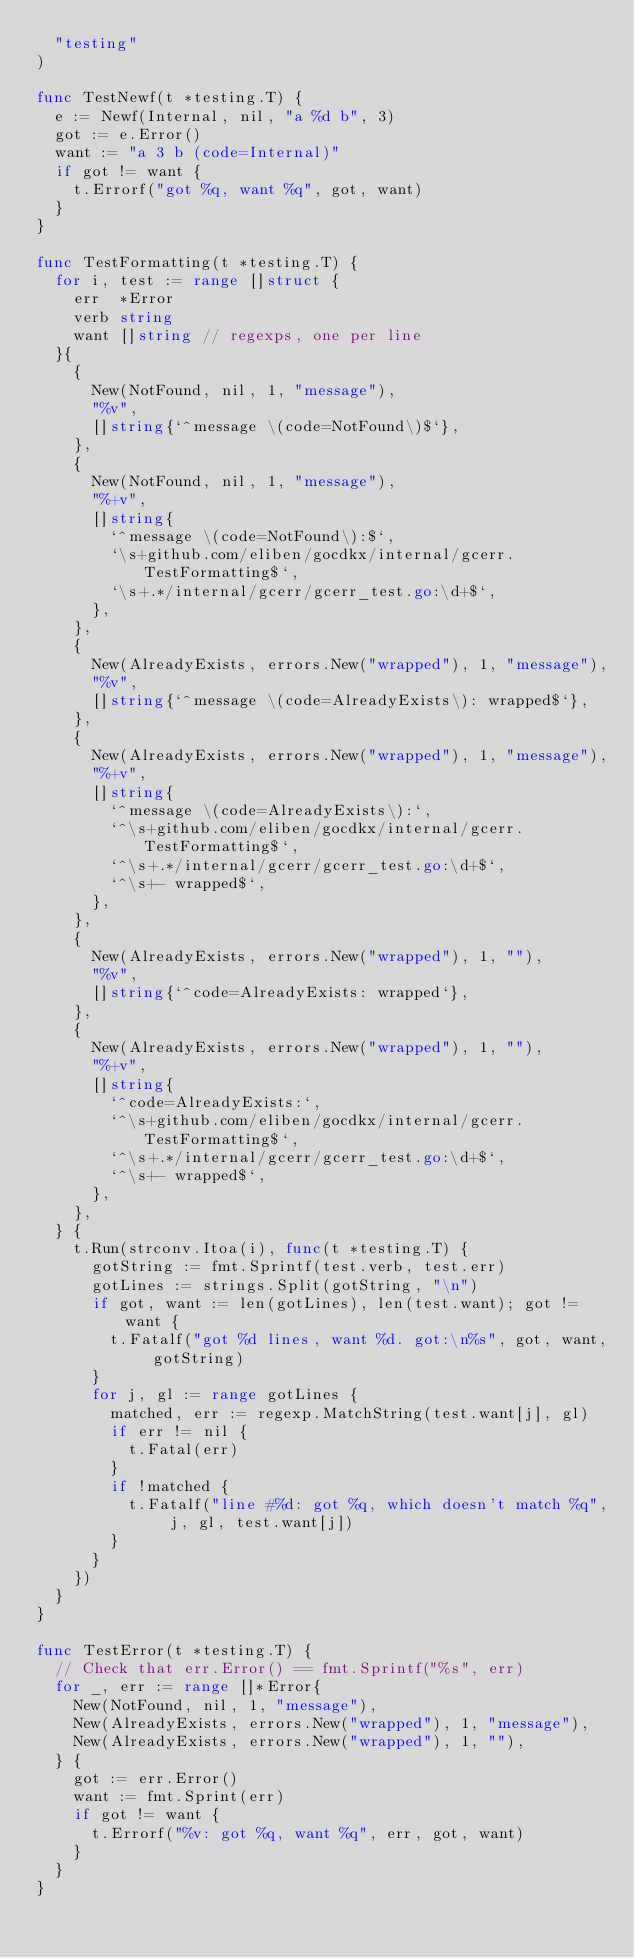Convert code to text. <code><loc_0><loc_0><loc_500><loc_500><_Go_>	"testing"
)

func TestNewf(t *testing.T) {
	e := Newf(Internal, nil, "a %d b", 3)
	got := e.Error()
	want := "a 3 b (code=Internal)"
	if got != want {
		t.Errorf("got %q, want %q", got, want)
	}
}

func TestFormatting(t *testing.T) {
	for i, test := range []struct {
		err  *Error
		verb string
		want []string // regexps, one per line
	}{
		{
			New(NotFound, nil, 1, "message"),
			"%v",
			[]string{`^message \(code=NotFound\)$`},
		},
		{
			New(NotFound, nil, 1, "message"),
			"%+v",
			[]string{
				`^message \(code=NotFound\):$`,
				`\s+github.com/eliben/gocdkx/internal/gcerr.TestFormatting$`,
				`\s+.*/internal/gcerr/gcerr_test.go:\d+$`,
			},
		},
		{
			New(AlreadyExists, errors.New("wrapped"), 1, "message"),
			"%v",
			[]string{`^message \(code=AlreadyExists\): wrapped$`},
		},
		{
			New(AlreadyExists, errors.New("wrapped"), 1, "message"),
			"%+v",
			[]string{
				`^message \(code=AlreadyExists\):`,
				`^\s+github.com/eliben/gocdkx/internal/gcerr.TestFormatting$`,
				`^\s+.*/internal/gcerr/gcerr_test.go:\d+$`,
				`^\s+- wrapped$`,
			},
		},
		{
			New(AlreadyExists, errors.New("wrapped"), 1, ""),
			"%v",
			[]string{`^code=AlreadyExists: wrapped`},
		},
		{
			New(AlreadyExists, errors.New("wrapped"), 1, ""),
			"%+v",
			[]string{
				`^code=AlreadyExists:`,
				`^\s+github.com/eliben/gocdkx/internal/gcerr.TestFormatting$`,
				`^\s+.*/internal/gcerr/gcerr_test.go:\d+$`,
				`^\s+- wrapped$`,
			},
		},
	} {
		t.Run(strconv.Itoa(i), func(t *testing.T) {
			gotString := fmt.Sprintf(test.verb, test.err)
			gotLines := strings.Split(gotString, "\n")
			if got, want := len(gotLines), len(test.want); got != want {
				t.Fatalf("got %d lines, want %d. got:\n%s", got, want, gotString)
			}
			for j, gl := range gotLines {
				matched, err := regexp.MatchString(test.want[j], gl)
				if err != nil {
					t.Fatal(err)
				}
				if !matched {
					t.Fatalf("line #%d: got %q, which doesn't match %q", j, gl, test.want[j])
				}
			}
		})
	}
}

func TestError(t *testing.T) {
	// Check that err.Error() == fmt.Sprintf("%s", err)
	for _, err := range []*Error{
		New(NotFound, nil, 1, "message"),
		New(AlreadyExists, errors.New("wrapped"), 1, "message"),
		New(AlreadyExists, errors.New("wrapped"), 1, ""),
	} {
		got := err.Error()
		want := fmt.Sprint(err)
		if got != want {
			t.Errorf("%v: got %q, want %q", err, got, want)
		}
	}
}
</code> 